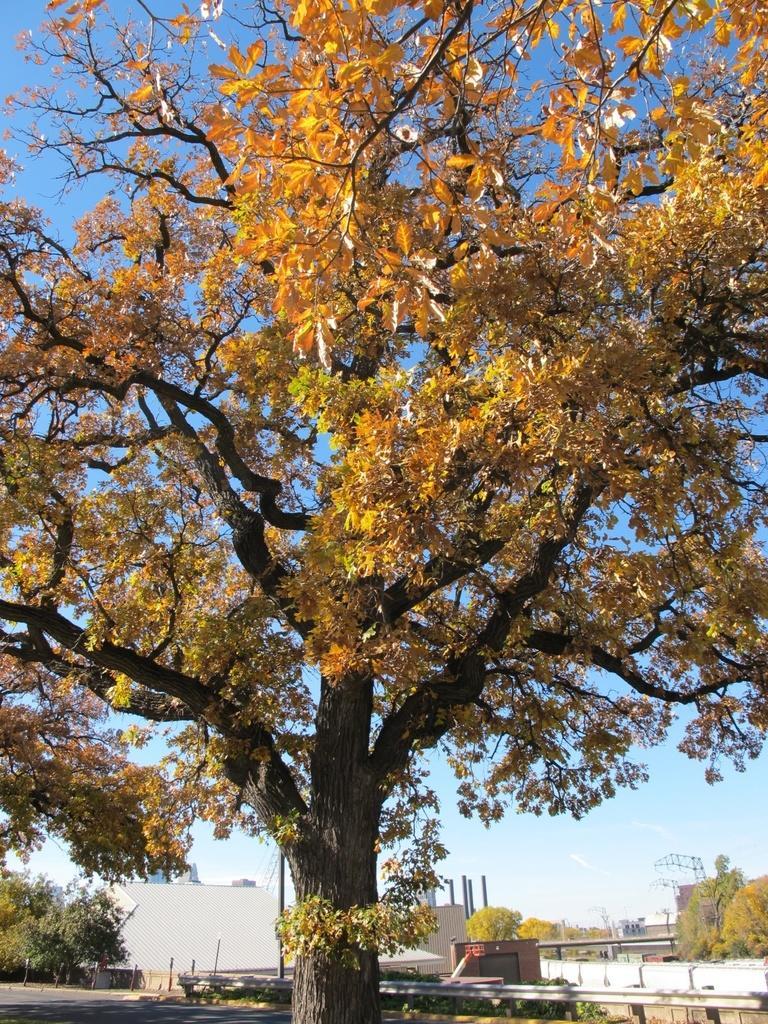Could you give a brief overview of what you see in this image? In this image we can see the trees. And we can see the shelter. And we can see the fencing. And we can see the poles. And in the bottom right hand corner we can see some object. And we can see the house. And we can see the basketball stand. 